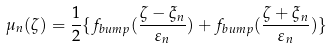<formula> <loc_0><loc_0><loc_500><loc_500>\mu _ { n } ( \zeta ) = \frac { 1 } { 2 } \{ f _ { b u m p } ( \frac { \zeta - \xi _ { n } } { \varepsilon _ { n } } ) + f _ { b u m p } ( \frac { \zeta + \xi _ { n } } { \varepsilon _ { n } } ) \}</formula> 